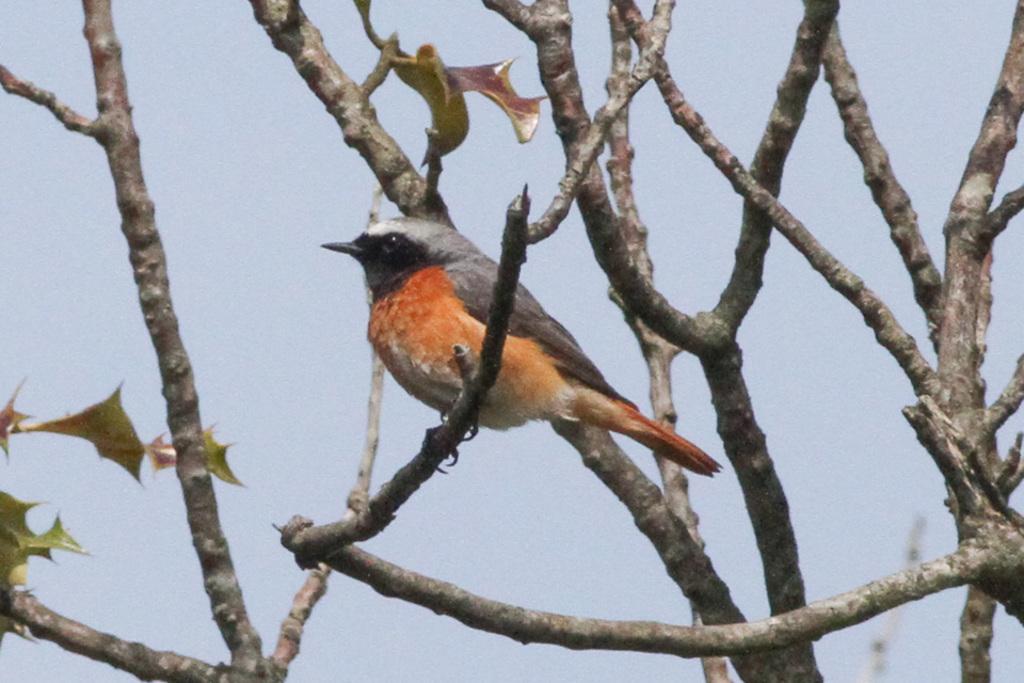Please provide a concise description of this image. There is a bird on the tree branch. 